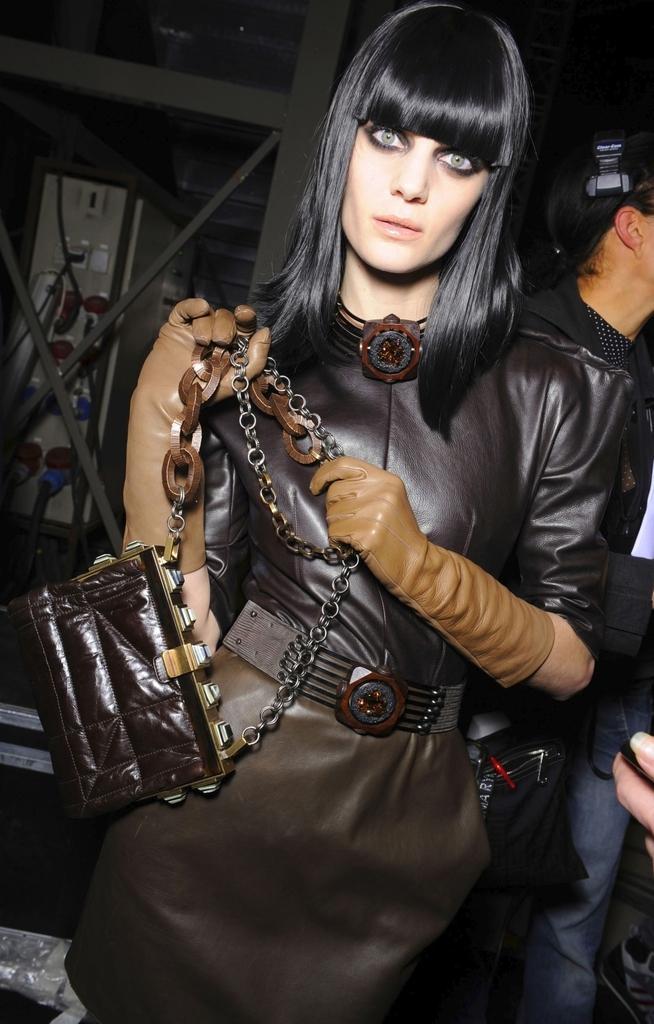Please provide a concise description of this image. In the image there is a woman who is wearing her gloves and holding her hand bag and background there is a man who is standing. 